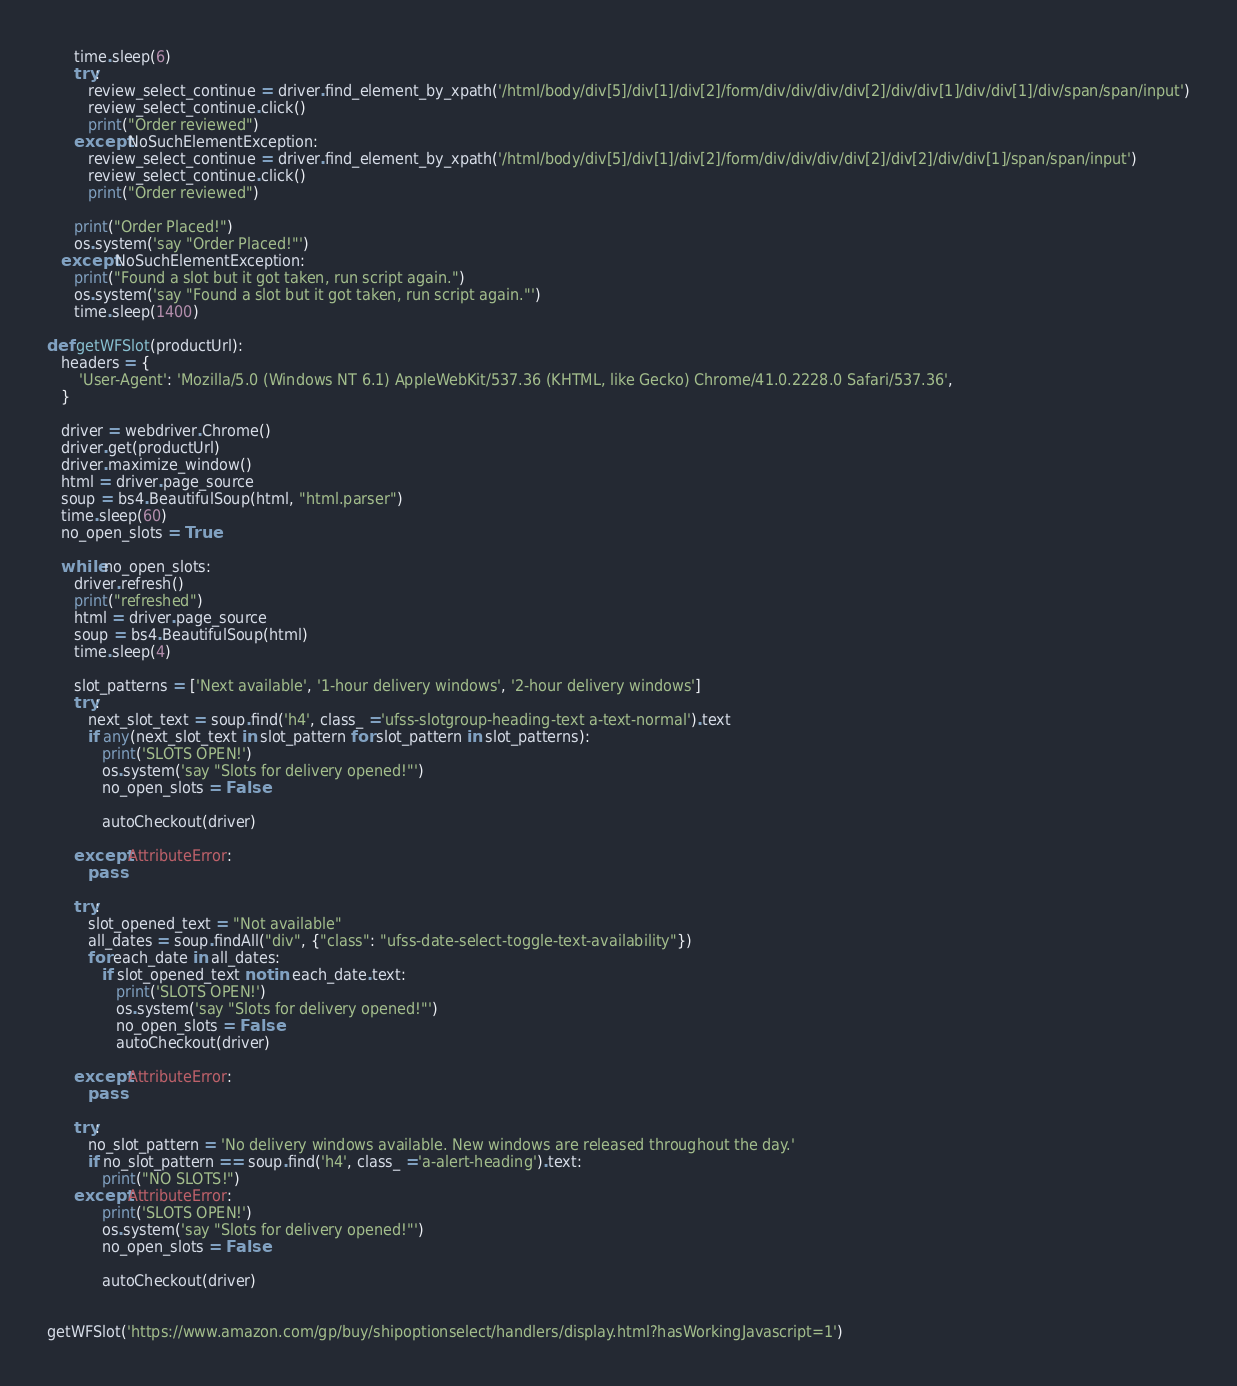Convert code to text. <code><loc_0><loc_0><loc_500><loc_500><_Python_>

      time.sleep(6)
      try:
         review_select_continue = driver.find_element_by_xpath('/html/body/div[5]/div[1]/div[2]/form/div/div/div/div[2]/div/div[1]/div/div[1]/div/span/span/input')
         review_select_continue.click()
         print("Order reviewed")
      except NoSuchElementException:
         review_select_continue = driver.find_element_by_xpath('/html/body/div[5]/div[1]/div[2]/form/div/div/div/div[2]/div[2]/div/div[1]/span/span/input')
         review_select_continue.click()
         print("Order reviewed")

      print("Order Placed!")
      os.system('say "Order Placed!"')
   except NoSuchElementException:
      print("Found a slot but it got taken, run script again.")
      os.system('say "Found a slot but it got taken, run script again."')
      time.sleep(1400)

def getWFSlot(productUrl):
   headers = {
       'User-Agent': 'Mozilla/5.0 (Windows NT 6.1) AppleWebKit/537.36 (KHTML, like Gecko) Chrome/41.0.2228.0 Safari/537.36',
   }

   driver = webdriver.Chrome()
   driver.get(productUrl)
   driver.maximize_window()         
   html = driver.page_source
   soup = bs4.BeautifulSoup(html, "html.parser")
   time.sleep(60)
   no_open_slots = True

   while no_open_slots:
      driver.refresh()
      print("refreshed")
      html = driver.page_source
      soup = bs4.BeautifulSoup(html)
      time.sleep(4)

      slot_patterns = ['Next available', '1-hour delivery windows', '2-hour delivery windows']
      try:
         next_slot_text = soup.find('h4', class_ ='ufss-slotgroup-heading-text a-text-normal').text
         if any(next_slot_text in slot_pattern for slot_pattern in slot_patterns):
            print('SLOTS OPEN!')
            os.system('say "Slots for delivery opened!"')
            no_open_slots = False

            autoCheckout(driver)
            
      except AttributeError:
         pass

      try:
         slot_opened_text = "Not available"
         all_dates = soup.findAll("div", {"class": "ufss-date-select-toggle-text-availability"})
         for each_date in all_dates:
            if slot_opened_text not in each_date.text:
               print('SLOTS OPEN!')
               os.system('say "Slots for delivery opened!"')
               no_open_slots = False
               autoCheckout(driver)

      except AttributeError:
         pass

      try:
         no_slot_pattern = 'No delivery windows available. New windows are released throughout the day.'
         if no_slot_pattern == soup.find('h4', class_ ='a-alert-heading').text:
            print("NO SLOTS!")
      except AttributeError: 
            print('SLOTS OPEN!')
            os.system('say "Slots for delivery opened!"')
            no_open_slots = False

            autoCheckout(driver)


getWFSlot('https://www.amazon.com/gp/buy/shipoptionselect/handlers/display.html?hasWorkingJavascript=1')


</code> 